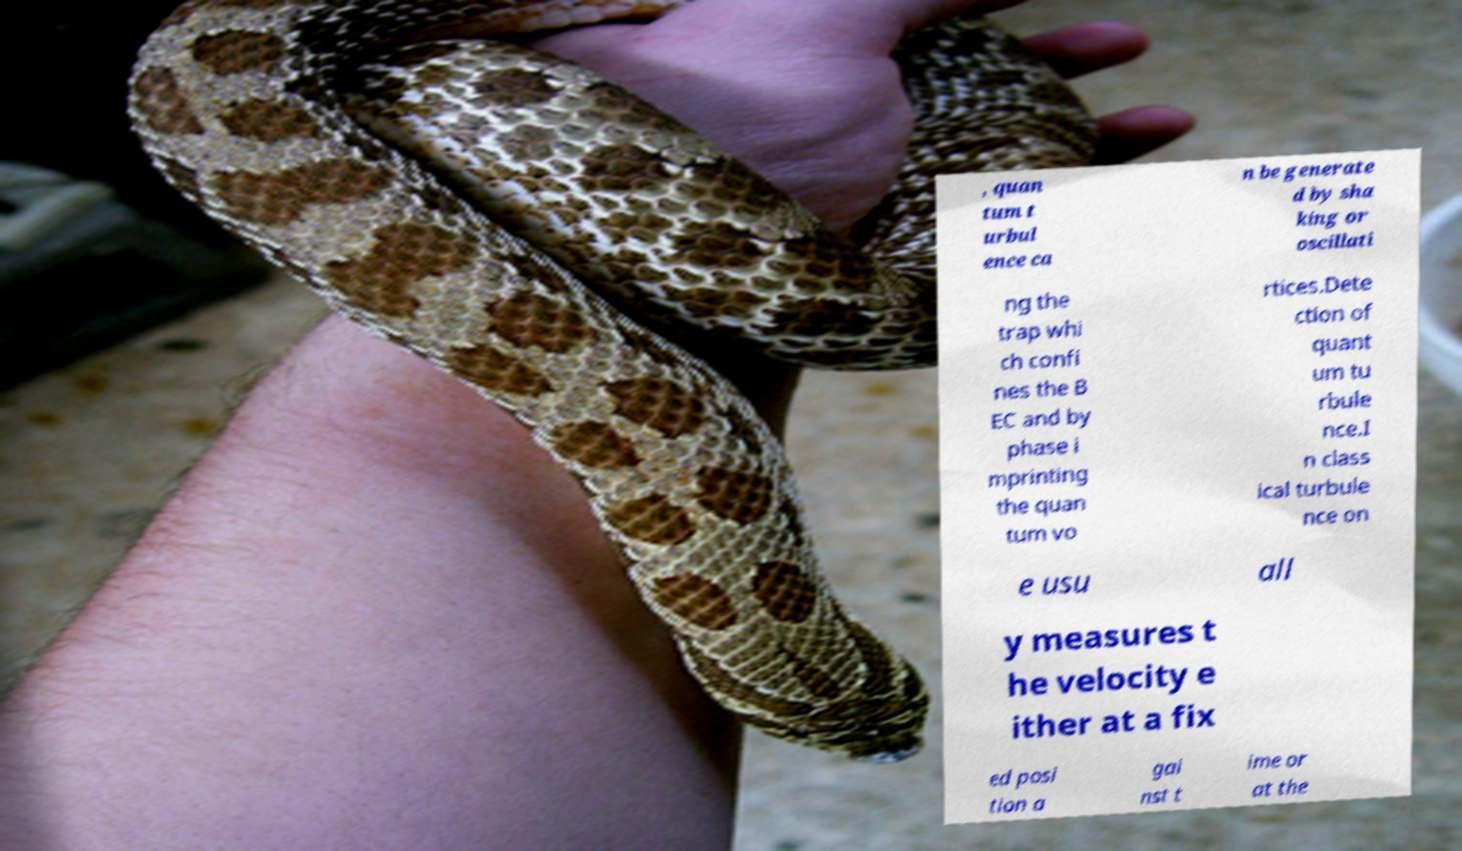Could you assist in decoding the text presented in this image and type it out clearly? , quan tum t urbul ence ca n be generate d by sha king or oscillati ng the trap whi ch confi nes the B EC and by phase i mprinting the quan tum vo rtices.Dete ction of quant um tu rbule nce.I n class ical turbule nce on e usu all y measures t he velocity e ither at a fix ed posi tion a gai nst t ime or at the 